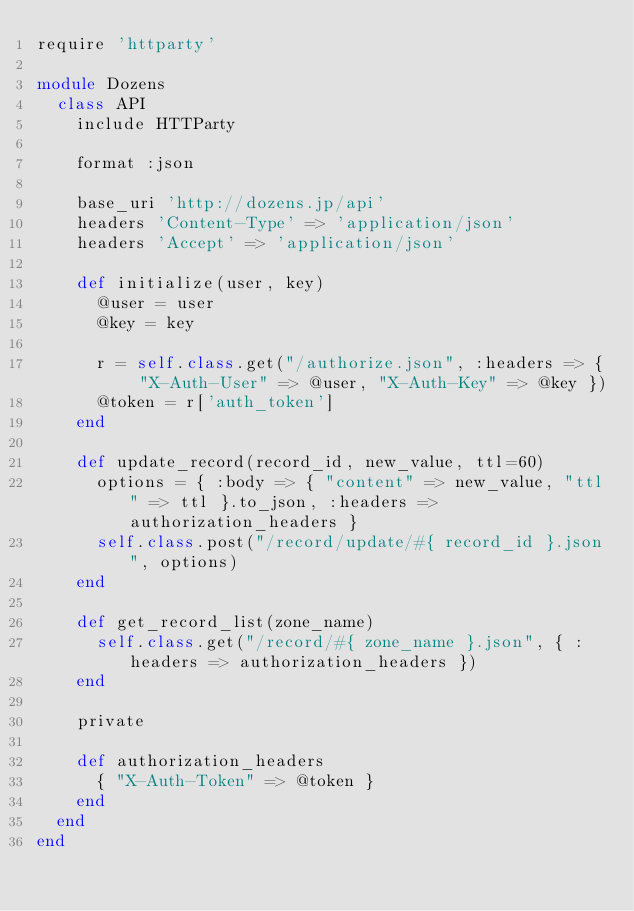<code> <loc_0><loc_0><loc_500><loc_500><_Ruby_>require 'httparty'

module Dozens
  class API
    include HTTParty

    format :json

    base_uri 'http://dozens.jp/api'
    headers 'Content-Type' => 'application/json'
    headers 'Accept' => 'application/json'

    def initialize(user, key)
      @user = user
      @key = key

      r = self.class.get("/authorize.json", :headers => { "X-Auth-User" => @user, "X-Auth-Key" => @key })
      @token = r['auth_token']
    end

    def update_record(record_id, new_value, ttl=60)
      options = { :body => { "content" => new_value, "ttl" => ttl }.to_json, :headers => authorization_headers }
      self.class.post("/record/update/#{ record_id }.json", options)
    end

    def get_record_list(zone_name)
      self.class.get("/record/#{ zone_name }.json", { :headers => authorization_headers })
    end

    private

    def authorization_headers
      { "X-Auth-Token" => @token }
    end
  end
end
</code> 